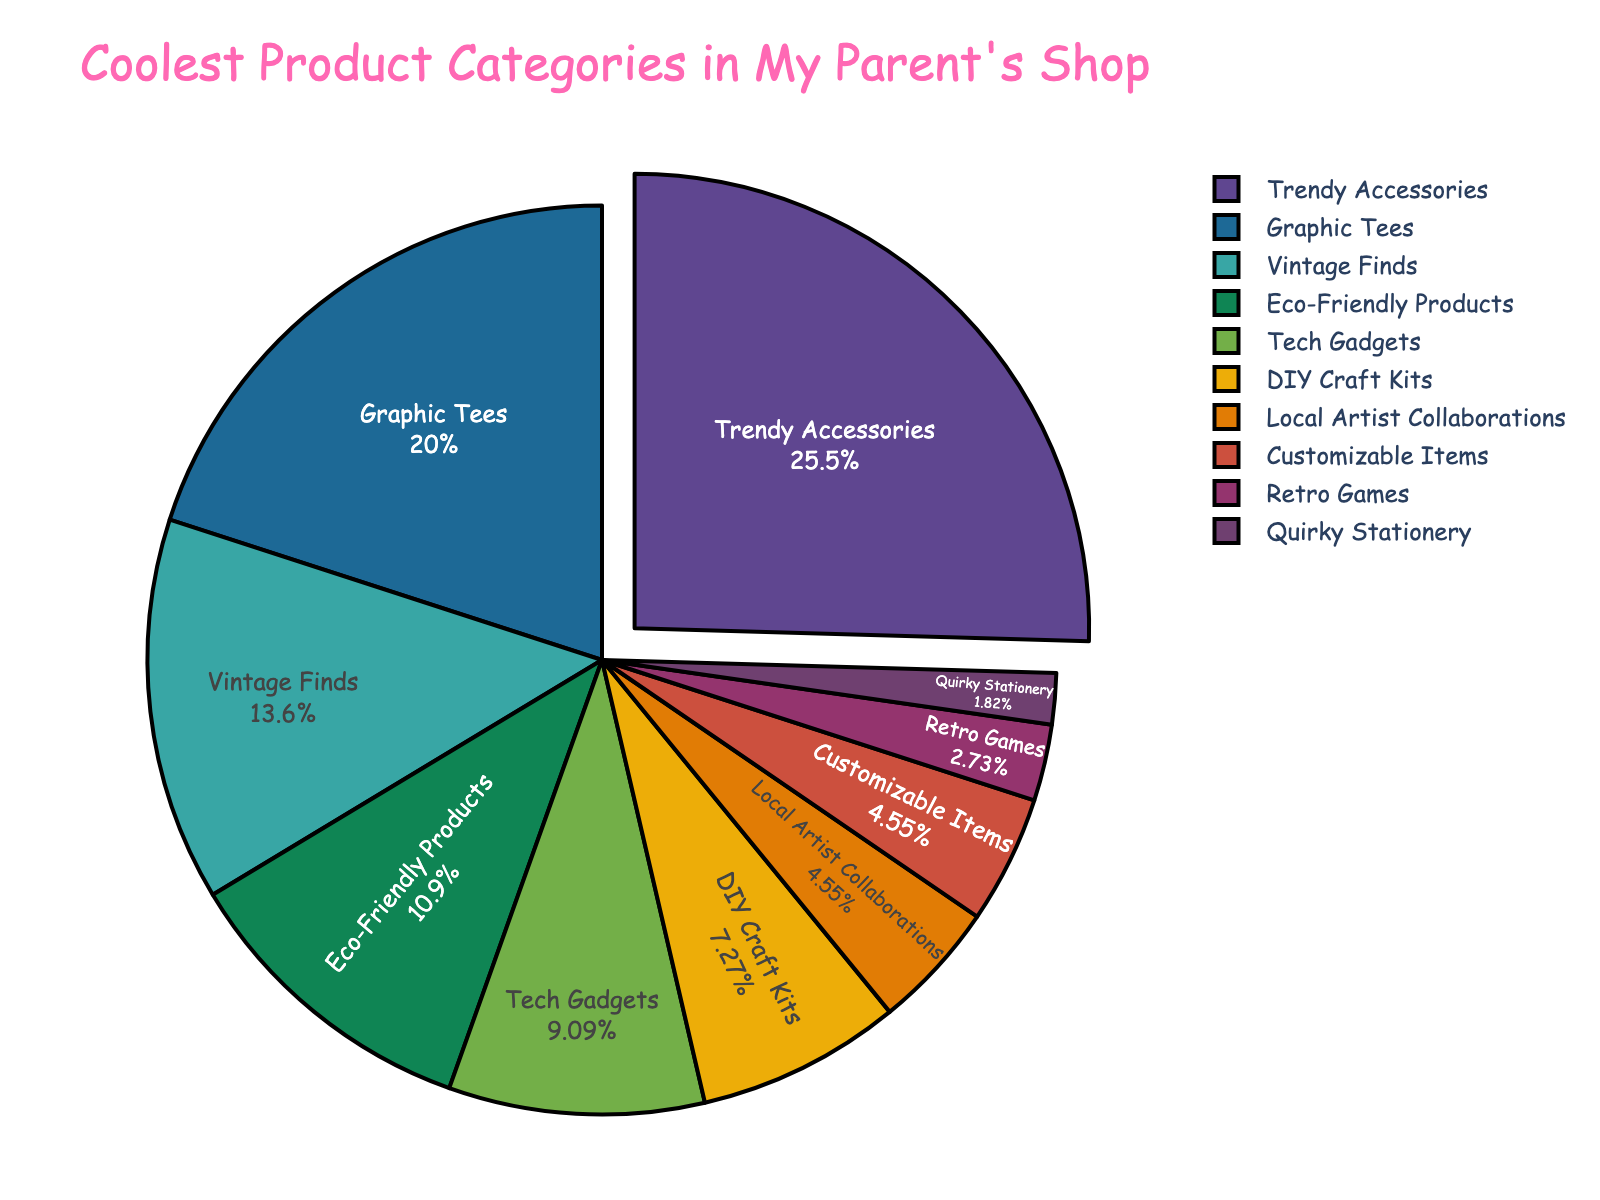Which product category is the most popular? The most popular product category is the one with the highest percentage, which is "Trendy Accessories" with 28%.
Answer: Trendy Accessories What is the combined percentage of "Graphic Tees" and "Vintage Finds"? To find the combined percentage, we add the percentages of "Graphic Tees" (22%) and "Vintage Finds" (15%). Therefore, 22% + 15% = 37%.
Answer: 37% Which two categories have the smallest percentages, and what are their combined percentages? The two categories with the smallest percentages are "Quirky Stationery" (2%) and "Retro Games" (3%). Their combined percentage is 2% + 3% = 5%.
Answer: Quirky Stationery and Retro Games, 5% Which category has a percentage closest to 10% without exceeding 10%? The category with a percentage closest to 10% without exceeding it is "DIY Craft Kits" with 8%.
Answer: DIY Craft Kits Are "Customizable Items" and "Local Artist Collaborations" equally popular? Yes, both categories have the same percentage of 5%, making them equally popular.
Answer: Yes What is the visual difference that stands out for the most popular category? The most popular category, "Trendy Accessories," is visually highlighted by being pulled out slightly from the rest of the pie chart.
Answer: Pulled out How much more popular are "Tech Gadgets" compared to "DIY Craft Kits"? "Tech Gadgets" have a percentage of 10%, and "DIY Craft Kits" have a percentage of 8%. The difference is 10% - 8% = 2%.
Answer: 2% What is the average percentage of the three least popular categories? The three least popular categories are "Quirky Stationery" (2%), "Retro Games" (3%), and "Customizable Items" (5%). The average is (2% + 3% + 5%) / 3 = 10% / 3 ≈ 3.33%.
Answer: 3.33% Which category is slightly more popular: "Eco-Friendly Products" or "Tech Gadgets"? "Eco-Friendly Products" have 12%, while "Tech Gadgets" have 10%. Therefore, "Eco-Friendly Products" is slightly more popular.
Answer: Eco-Friendly Products What is the sum of the percentages for categories that are related to art or creativity ("Local Artist Collaborations" and "DIY Craft Kits")? The categories related to art or creativity are "Local Artist Collaborations" (5%) and "DIY Craft Kits" (8%). The sum is 5% + 8% = 13%.
Answer: 13% 